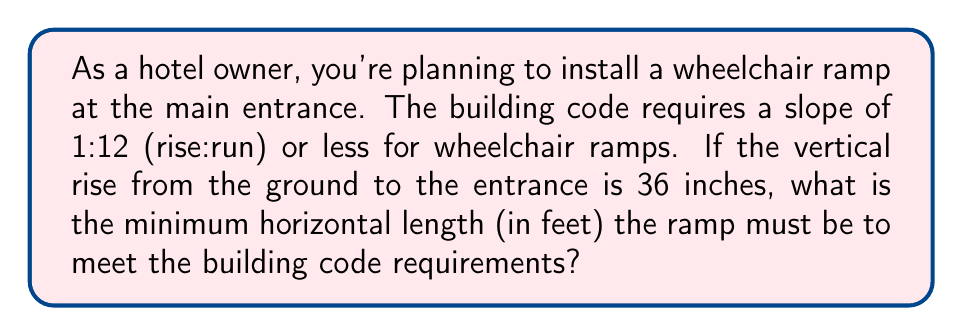Can you answer this question? Let's approach this step-by-step:

1) The slope requirement of 1:12 means for every 1 unit of rise, there must be at least 12 units of run.

2) We're given a vertical rise of 36 inches. Let's call the required horizontal length $x$ inches.

3) We can set up the following proportion:
   $$\frac{1}{12} = \frac{36}{x}$$

4) Cross multiply:
   $$1 \cdot x = 12 \cdot 36$$
   $$x = 12 \cdot 36 = 432$$

5) So, the minimum horizontal length is 432 inches.

6) The question asks for the answer in feet, so we need to convert:
   $$432 \text{ inches} \cdot \frac{1 \text{ foot}}{12 \text{ inches}} = 36 \text{ feet}$$

Therefore, the ramp must be at least 36 feet long to meet the building code requirements.
Answer: 36 feet 